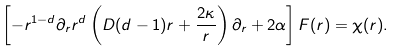Convert formula to latex. <formula><loc_0><loc_0><loc_500><loc_500>\left [ - r ^ { 1 - d } \partial _ { r } r ^ { d } \left ( D ( d - 1 ) r + \frac { 2 \kappa } { r } \right ) \partial _ { r } + 2 \alpha \right ] F ( r ) = \chi ( r ) .</formula> 